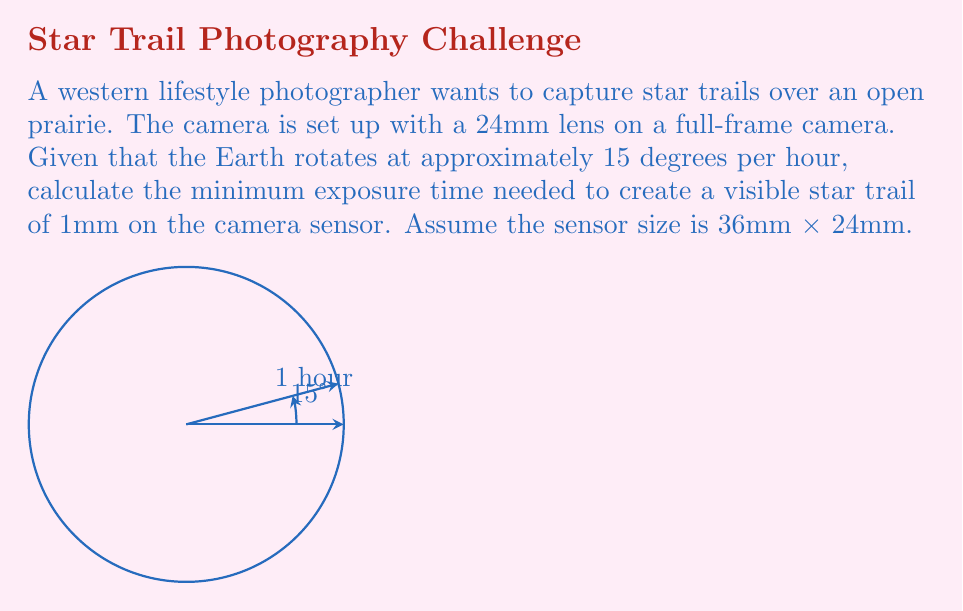Help me with this question. Let's approach this step-by-step:

1) First, we need to determine the angular field of view (FOV) of the lens. For a 24mm lens on a 36mm wide sensor:

   $$\text{FOV} = 2 \arctan(\frac{18}{24}) \approx 73.74°$$

2) Now, we need to find how many millimeters on the sensor correspond to 1° in the sky:

   $$\frac{36 \text{ mm}}{73.74°} \approx 0.4882 \text{ mm/°}$$

3) We want a 1mm trail, so we need to determine how many degrees this corresponds to:

   $$1 \text{ mm} \div 0.4882 \text{ mm/°} \approx 2.0483°$$

4) Given that the Earth rotates at 15° per hour, we can calculate the time needed for a 2.0483° rotation:

   $$\frac{2.0483°}{15°/\text{hour}} \approx 0.1366 \text{ hours}$$

5) Converting to minutes:

   $$0.1366 \text{ hours} \times 60 \text{ min/hour} \approx 8.196 \text{ minutes}$$

Therefore, the minimum exposure time needed is approximately 8.2 minutes.
Answer: 8.2 minutes 